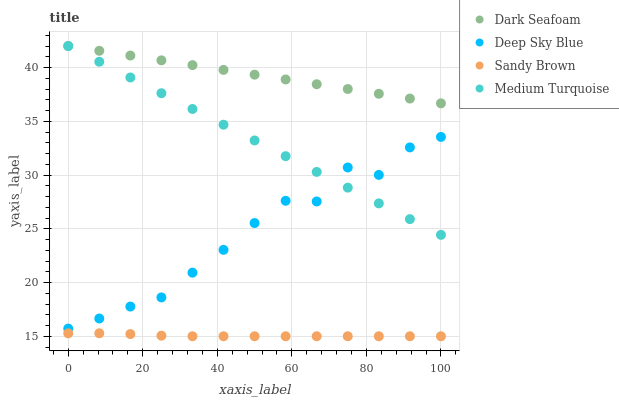Does Sandy Brown have the minimum area under the curve?
Answer yes or no. Yes. Does Dark Seafoam have the maximum area under the curve?
Answer yes or no. Yes. Does Medium Turquoise have the minimum area under the curve?
Answer yes or no. No. Does Medium Turquoise have the maximum area under the curve?
Answer yes or no. No. Is Medium Turquoise the smoothest?
Answer yes or no. Yes. Is Deep Sky Blue the roughest?
Answer yes or no. Yes. Is Sandy Brown the smoothest?
Answer yes or no. No. Is Sandy Brown the roughest?
Answer yes or no. No. Does Sandy Brown have the lowest value?
Answer yes or no. Yes. Does Medium Turquoise have the lowest value?
Answer yes or no. No. Does Medium Turquoise have the highest value?
Answer yes or no. Yes. Does Sandy Brown have the highest value?
Answer yes or no. No. Is Sandy Brown less than Deep Sky Blue?
Answer yes or no. Yes. Is Medium Turquoise greater than Sandy Brown?
Answer yes or no. Yes. Does Dark Seafoam intersect Medium Turquoise?
Answer yes or no. Yes. Is Dark Seafoam less than Medium Turquoise?
Answer yes or no. No. Is Dark Seafoam greater than Medium Turquoise?
Answer yes or no. No. Does Sandy Brown intersect Deep Sky Blue?
Answer yes or no. No. 